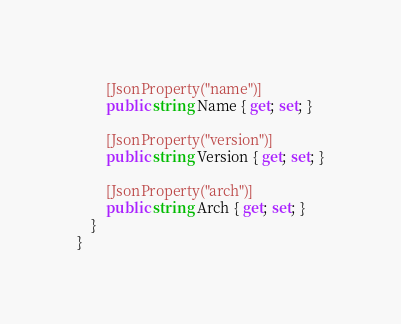<code> <loc_0><loc_0><loc_500><loc_500><_C#_>        [JsonProperty("name")]
        public string Name { get; set; }

        [JsonProperty("version")]
        public string Version { get; set; }

        [JsonProperty("arch")]
        public string Arch { get; set; }
    }
}</code> 